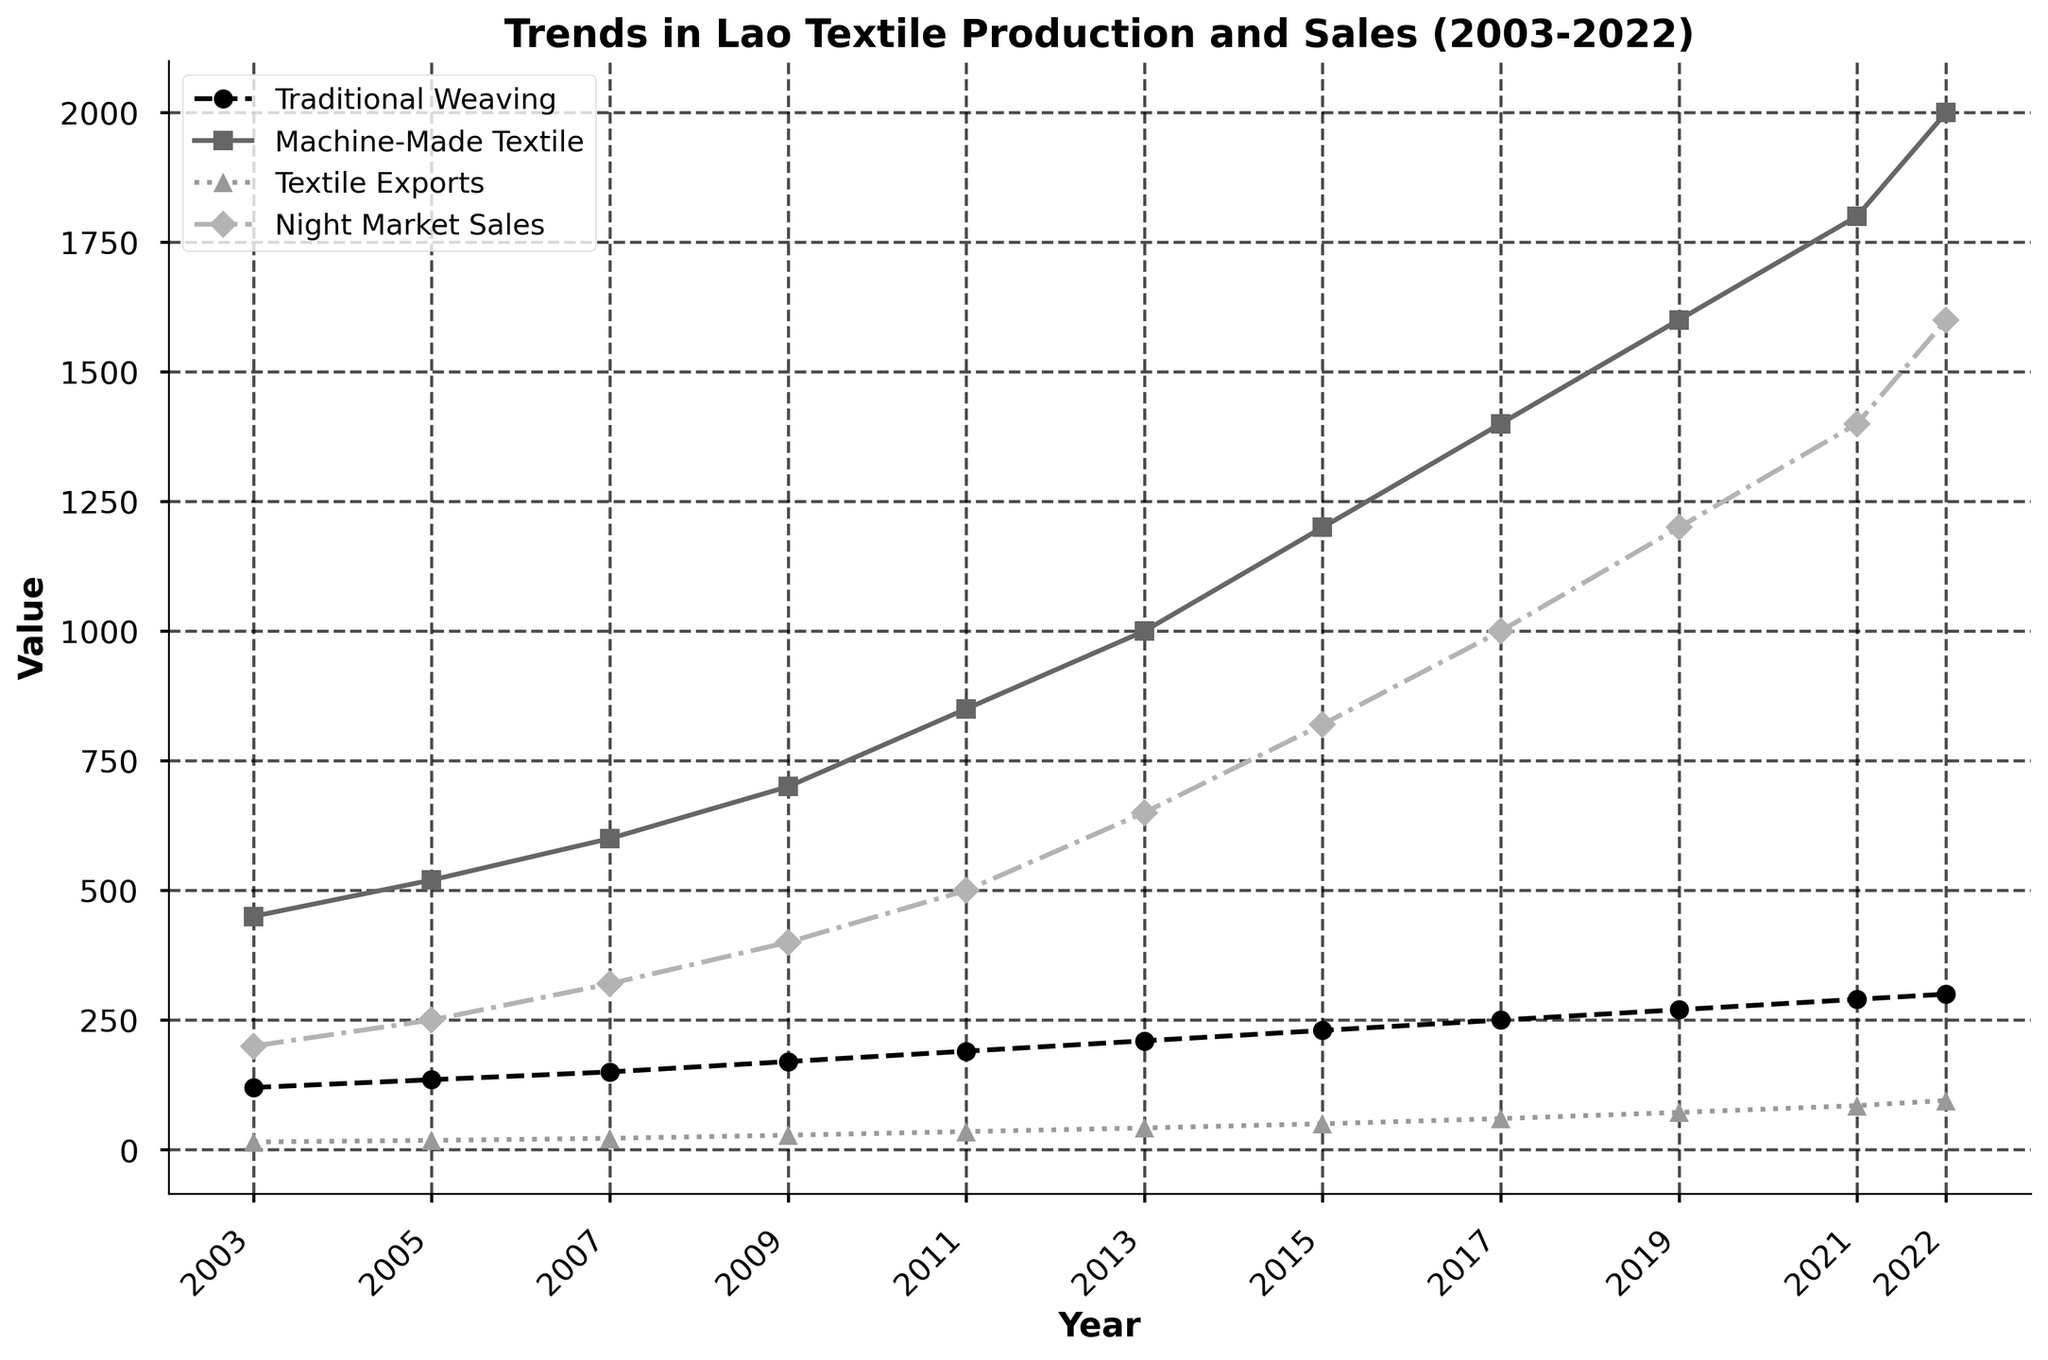How did the production of traditional weaving compare to machine-made textiles in 2003? Follow the line that represents traditional weaving production in 2003 and note its value. Do the same for machine-made textile production. Compare the two values.
Answer: Traditional weaving: 120, Machine-made: 450 What was the percentage increase in the Textile Exports Value from 2009 to 2022? Calculate the difference between the Textile Exports Value in 2022 and 2009. Divide this difference by the value in 2009 and multiply by 100 to get the percentage increase. \((95 - 28) / 28 \times 100 = \approx 239.3\%\)
Answer: Approximately 239.3% Which data series shows the highest increase in value from 2003 to 2022? Compare each line's starting and ending point values from 2003 to 2022. Identify the series with the highest numeric increase. Machine-made textile production increased from 450 to 2000.
Answer: Machine-Made Textile Production What is the average sales value at the Luang Prabang Night Market from 2003 to 2022? Sum the yearly sales values and divide by the number of years. \((200 + 250 + 320 + 400 + 500 + 650 + 820 + 1000 + 1200 + 1400 + 1600) / 11 \approx 763.6\)
Answer: Approximately 764 In which year did traditional weaving production reach 250,000 pieces? Follow the line for traditional weaving production and identify the year where it first crosses 250 on the y-axis.
Answer: 2017 What was the total textile export value over the last 20 years? Sum the Textile Exports Value for all given years. \(15 + 18 + 22 + 28 + 35 + 42 + 50 + 60 + 72 + 85 + 95 = 522\) million USD
Answer: 522 million USD Is the pattern of increase in machine-made textile production more linear or exponential? Examine the trend of the line for machine-made textile, focusing on whether the increments seem consistent (linear) or increase more rapidly over time (exponential). The trend is more exponential.
Answer: Exponential How much did the Luang Prabang Night Market sales increase from 2013 to 2022? Look at the sales values in 2013 and 2022, then calculate the difference. \(1600 - 650 = 950\)
Answer: 950 Which production type, traditional or machine-made, had a higher growth rate from 2019 to 2022? Calculate the growth for each production type: Traditional \(300 - 270 = 30\); Machine-made \(2000 - 1600 = 400\). Compare the values.
Answer: Machine-Made Textile Production What trend is noticeable in traditional weaving production over the 20 years? Observe the line representing traditional weaving production to identify the pattern – whether it steadily increases, decreases, or fluctuates. It steadily increases.
Answer: Steadily increases 